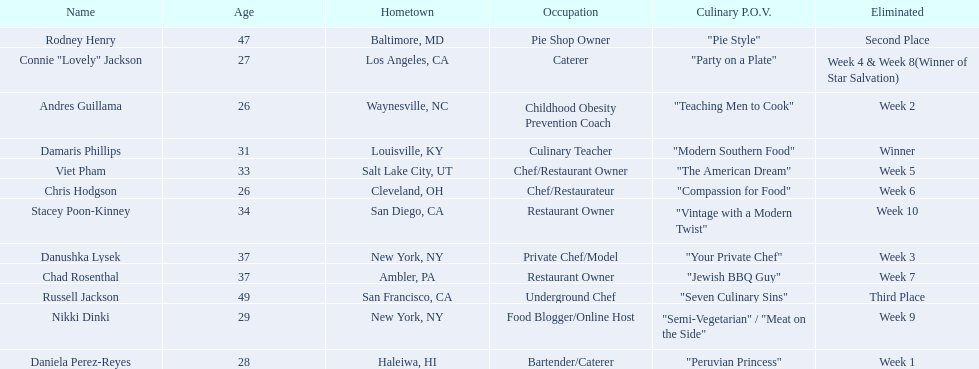Who are the  food network stars? Damaris Phillips, Rodney Henry, Russell Jackson, Stacey Poon-Kinney, Nikki Dinki, Chad Rosenthal, Chris Hodgson, Viet Pham, Connie "Lovely" Jackson, Danushka Lysek, Andres Guillama, Daniela Perez-Reyes. When did nikki dinki get eliminated? Week 9. When did viet pham get eliminated? Week 5. Which week came first? Week 5. Who was it that was eliminated week 5? Viet Pham. 